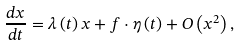Convert formula to latex. <formula><loc_0><loc_0><loc_500><loc_500>\frac { d x } { d t } = \lambda \left ( t \right ) x + f \cdot \eta \left ( t \right ) + O \left ( x ^ { 2 } \right ) ,</formula> 